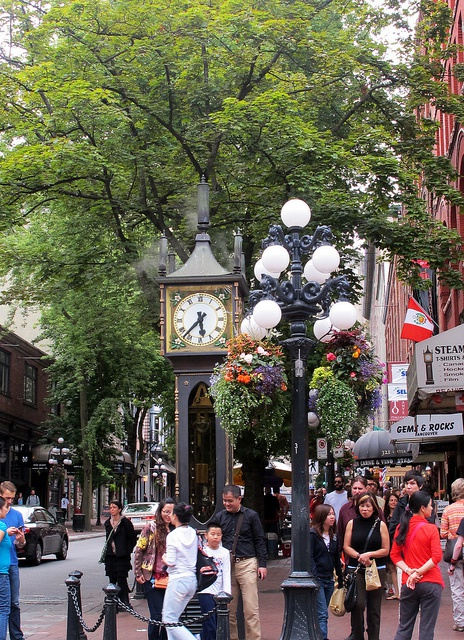Describe the objects in this image and their specific colors. I can see people in beige, black, red, purple, and salmon tones, people in beige, black, salmon, brown, and maroon tones, people in beige, black, gray, maroon, and darkgray tones, people in beige, black, brown, and tan tones, and people in beige, lavender, black, darkgray, and maroon tones in this image. 